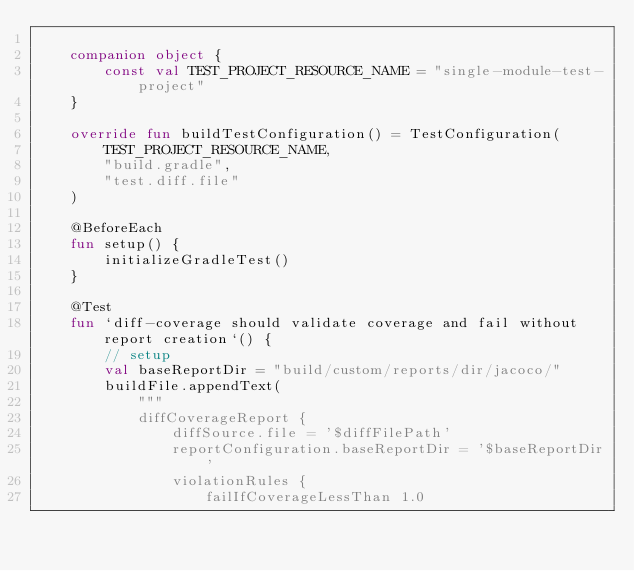<code> <loc_0><loc_0><loc_500><loc_500><_Kotlin_>
    companion object {
        const val TEST_PROJECT_RESOURCE_NAME = "single-module-test-project"
    }

    override fun buildTestConfiguration() = TestConfiguration(
        TEST_PROJECT_RESOURCE_NAME,
        "build.gradle",
        "test.diff.file"
    )

    @BeforeEach
    fun setup() {
        initializeGradleTest()
    }

    @Test
    fun `diff-coverage should validate coverage and fail without report creation`() {
        // setup
        val baseReportDir = "build/custom/reports/dir/jacoco/"
        buildFile.appendText(
            """
            diffCoverageReport {
                diffSource.file = '$diffFilePath'
                reportConfiguration.baseReportDir = '$baseReportDir'
                violationRules {
                    failIfCoverageLessThan 1.0</code> 